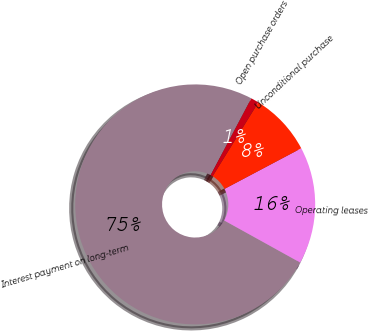<chart> <loc_0><loc_0><loc_500><loc_500><pie_chart><fcel>Interest payment on long-term<fcel>Operating leases<fcel>Unconditional purchase<fcel>Open purchase orders<nl><fcel>74.7%<fcel>15.8%<fcel>8.43%<fcel>1.07%<nl></chart> 